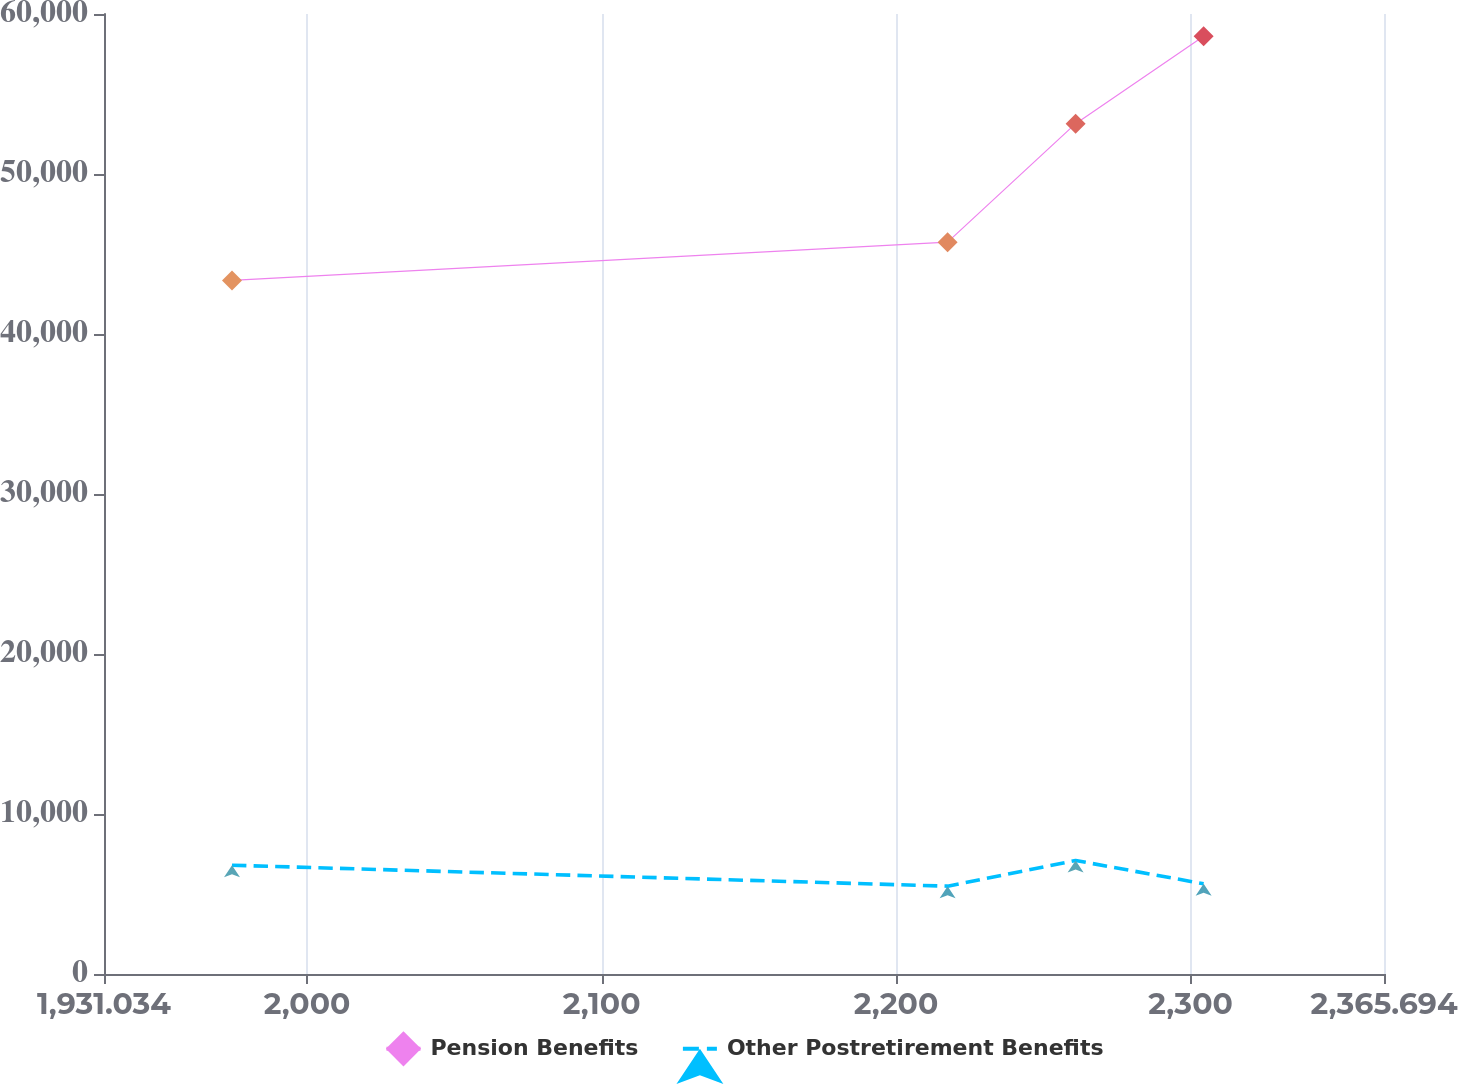Convert chart. <chart><loc_0><loc_0><loc_500><loc_500><line_chart><ecel><fcel>Pension Benefits<fcel>Other Postretirement Benefits<nl><fcel>1974.5<fcel>43350.8<fcel>6797.51<nl><fcel>2217.5<fcel>45740.1<fcel>5490.14<nl><fcel>2260.97<fcel>53145<fcel>7093.99<nl><fcel>2304.44<fcel>58602.7<fcel>5638.38<nl><fcel>2409.16<fcel>51619.8<fcel>6945.75<nl></chart> 